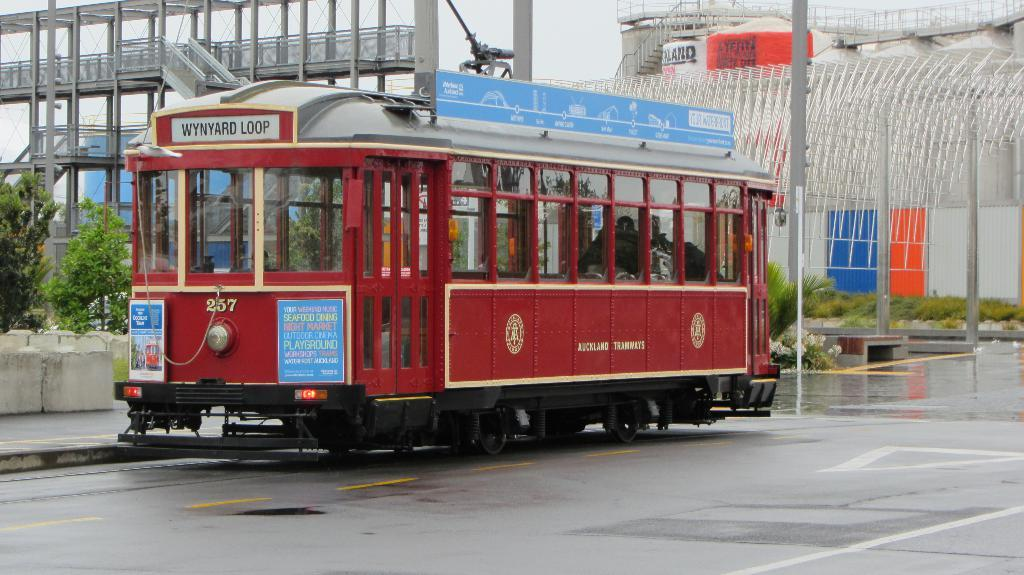What is on the road in the image? There is a vehicle on the road in the image. What type of natural environment is visible in the image? There is grass and trees visible in the image. What type of man-made structures can be seen in the image? There are posters in the image. What else can be seen in the image besides the vehicle, grass, trees, and posters? There are some objects in the image. What is visible in the background of the image? The sky is visible in the background of the image. What type of cherries are hanging from the trees in the image? There are no cherries visible in the image; only trees are present. What historical event is being commemorated by the posters in the image? The image does not provide any information about the content of the posters, so it is impossible to determine if they are related to a historical event. 